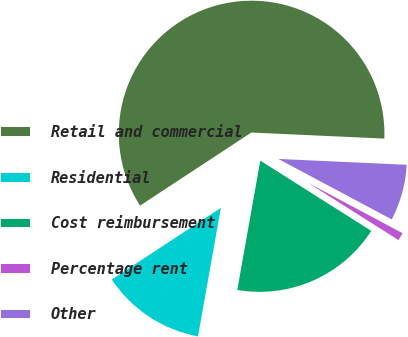Convert chart to OTSL. <chart><loc_0><loc_0><loc_500><loc_500><pie_chart><fcel>Retail and commercial<fcel>Residential<fcel>Cost reimbursement<fcel>Percentage rent<fcel>Other<nl><fcel>59.98%<fcel>12.95%<fcel>18.82%<fcel>1.19%<fcel>7.07%<nl></chart> 